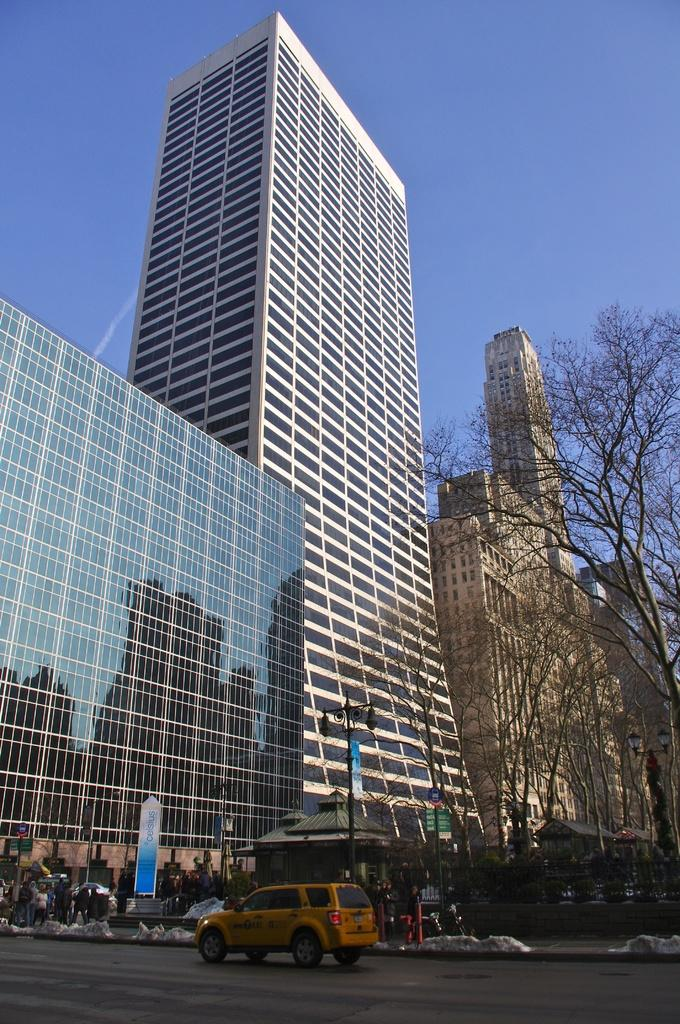What structures are located in the center of the image? There are buildings in the center of the image. What is at the bottom of the image? There is a car and a shed at the bottom of the image. What else can be seen in the image besides the buildings and the car? There are poles visible in the image. What can be seen in the background of the image? There are trees and the sky visible in the background of the image. What type of salt is sprinkled on the trees in the image? There is no salt present in the image; it features buildings, a car, a shed, poles, trees, and the sky. Can you see any bones in the image? There are no bones visible in the image. 